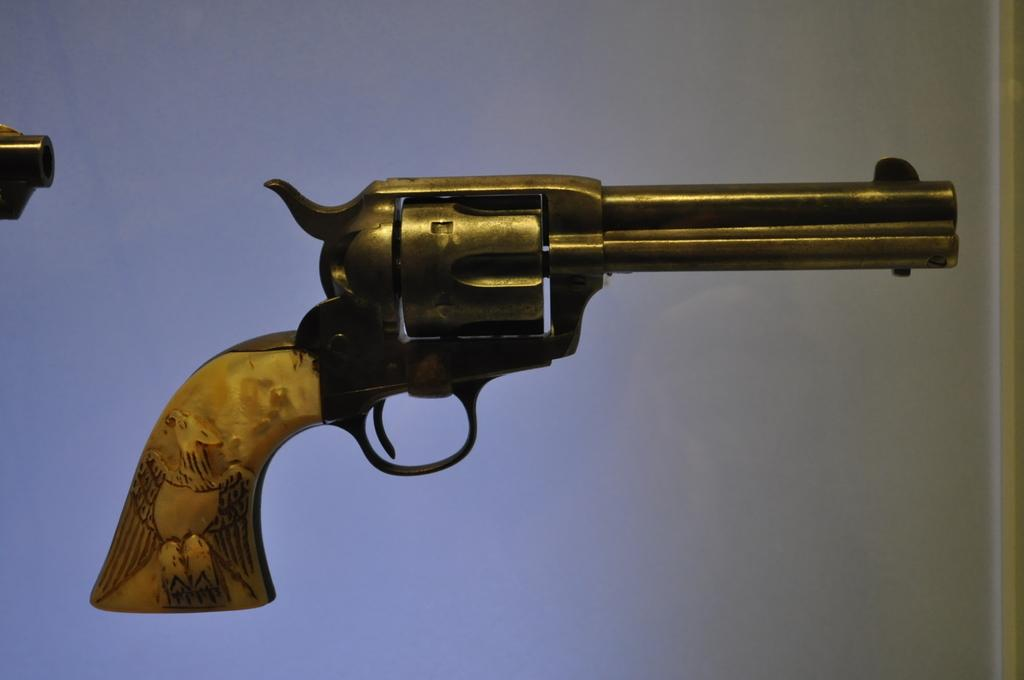What is the main object in the center of the image? There is a gun in the center of the image. What can be seen in the background of the image? There is a wall in the background of the image. What is located on the left side of the image? There is an object on the left side of the image. How many ducks are visible in the image? There are no ducks present in the image. What type of line is used to draw the object on the left side of the image? The image is a photograph, not a drawing, so there is no line used to draw the object. 